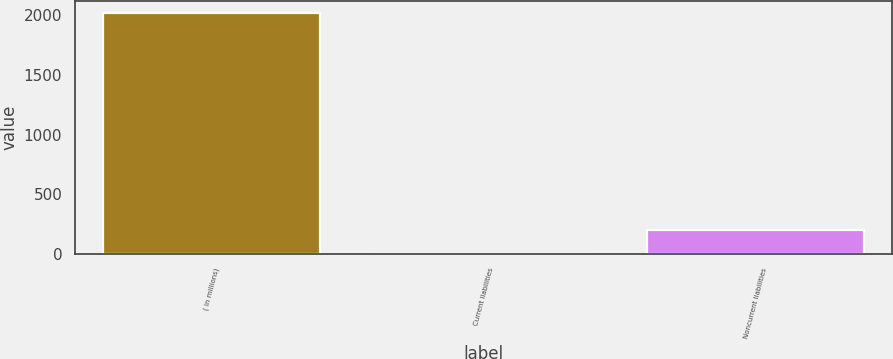<chart> <loc_0><loc_0><loc_500><loc_500><bar_chart><fcel>( in millions)<fcel>Current liabilities<fcel>Noncurrent liabilities<nl><fcel>2016<fcel>1.5<fcel>202.95<nl></chart> 